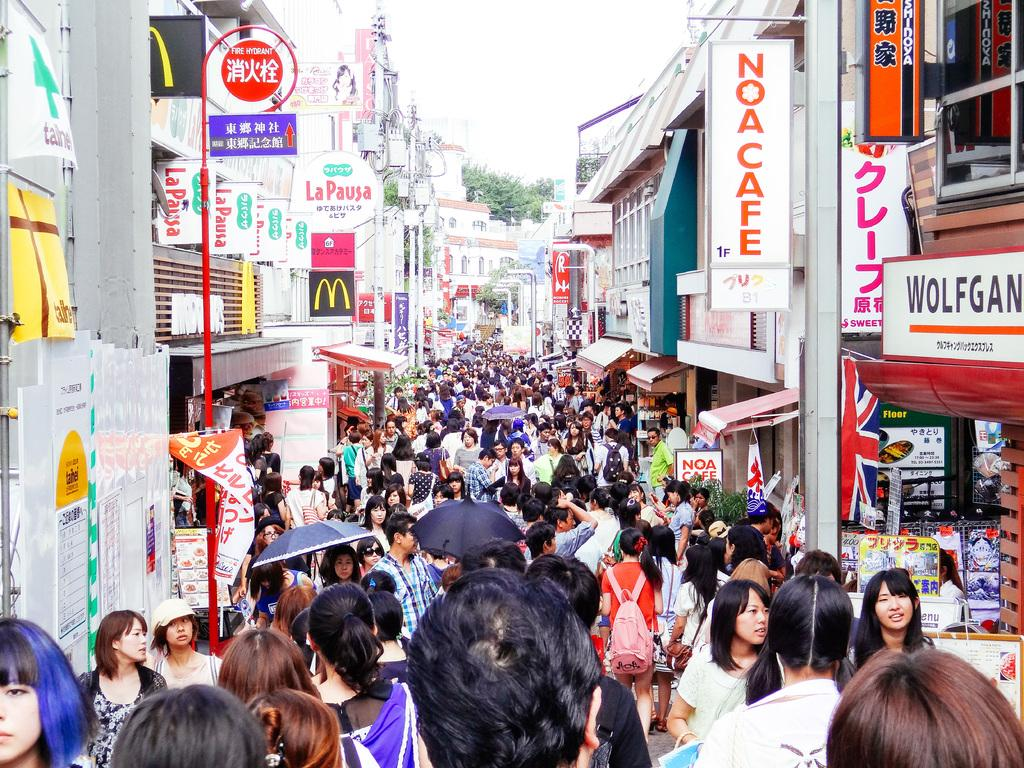What is the main feature of the image? There is a huge crowd in the image. What can be seen on either side of the crowd? There are buildings on the left and right sides of the image. What is attached to the buildings? There are boards associated with the buildings. What is visible at the top of the image? The sky is visible at the top of the image. What type of vegetation can be seen in the background? There is a tree in the background of the image. What type of advertisement can be seen on the rod in the image? There is no rod present in the image, and therefore no advertisement can be observed. What type of fowl is perched on the tree in the background? There is no fowl present on the tree in the background; only the tree itself is visible. 